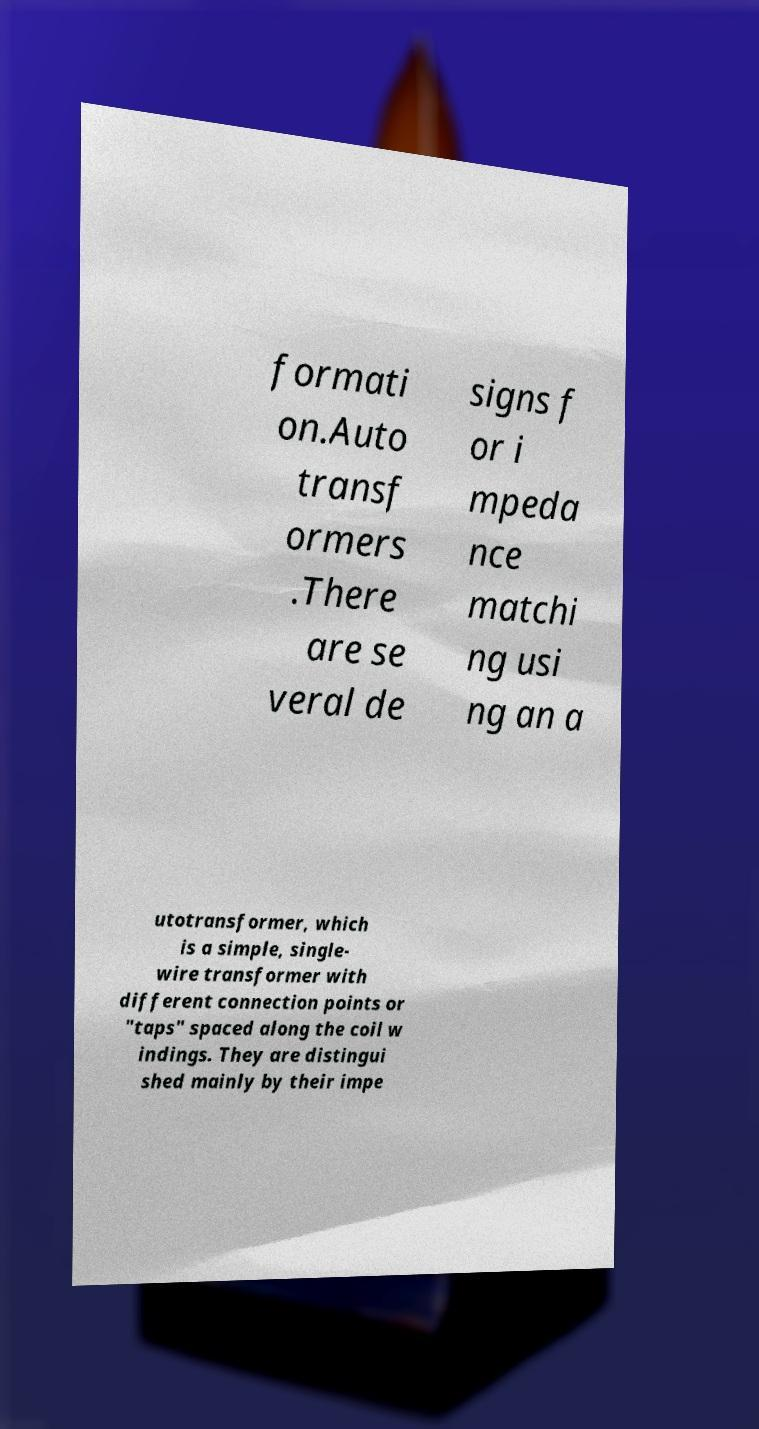I need the written content from this picture converted into text. Can you do that? formati on.Auto transf ormers .There are se veral de signs f or i mpeda nce matchi ng usi ng an a utotransformer, which is a simple, single- wire transformer with different connection points or "taps" spaced along the coil w indings. They are distingui shed mainly by their impe 